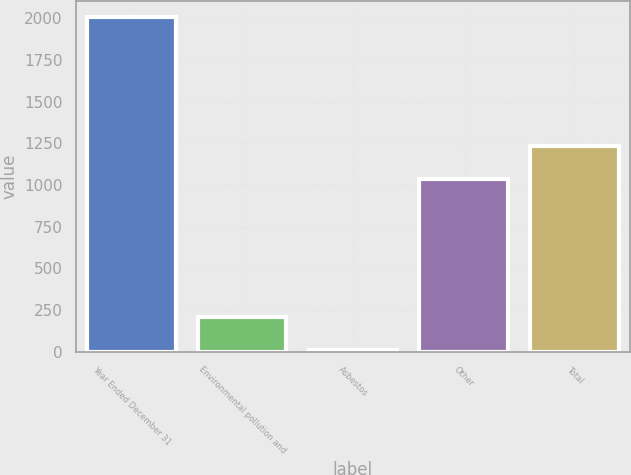Convert chart. <chart><loc_0><loc_0><loc_500><loc_500><bar_chart><fcel>Year Ended December 31<fcel>Environmental pollution and<fcel>Asbestos<fcel>Other<fcel>Total<nl><fcel>2005<fcel>209.5<fcel>10<fcel>1037<fcel>1236.5<nl></chart> 